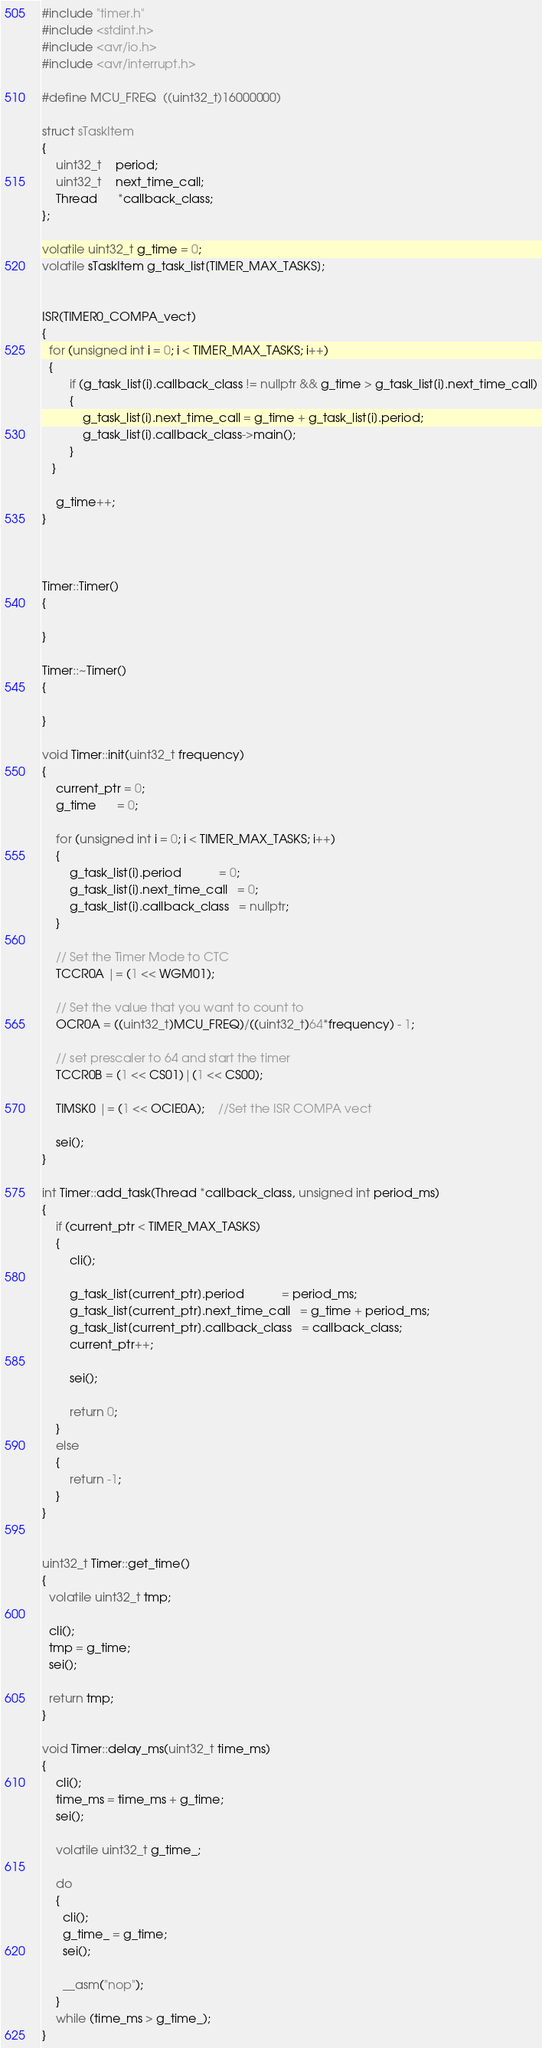Convert code to text. <code><loc_0><loc_0><loc_500><loc_500><_C++_>#include "timer.h"
#include <stdint.h>
#include <avr/io.h>
#include <avr/interrupt.h>

#define MCU_FREQ  ((uint32_t)16000000)

struct sTaskItem
{
    uint32_t    period;
    uint32_t    next_time_call;
    Thread      *callback_class;
};

volatile uint32_t g_time = 0;
volatile sTaskItem g_task_list[TIMER_MAX_TASKS];

 
ISR(TIMER0_COMPA_vect)
{
  for (unsigned int i = 0; i < TIMER_MAX_TASKS; i++)
  {
        if (g_task_list[i].callback_class != nullptr && g_time > g_task_list[i].next_time_call)
        {
            g_task_list[i].next_time_call = g_time + g_task_list[i].period;
            g_task_list[i].callback_class->main();
        }
   }

    g_time++;
}



Timer::Timer()
{
    
} 

Timer::~Timer()
{

}

void Timer::init(uint32_t frequency)
{
    current_ptr = 0;
    g_time      = 0;

    for (unsigned int i = 0; i < TIMER_MAX_TASKS; i++)
    {
        g_task_list[i].period           = 0;
        g_task_list[i].next_time_call   = 0;
        g_task_list[i].callback_class   = nullptr;
    }

    // Set the Timer Mode to CTC
    TCCR0A |= (1 << WGM01);

    // Set the value that you want to count to
    OCR0A = ((uint32_t)MCU_FREQ)/((uint32_t)64*frequency) - 1;
  
    // set prescaler to 64 and start the timer
    TCCR0B = (1 << CS01)|(1 << CS00);

    TIMSK0 |= (1 << OCIE0A);    //Set the ISR COMPA vect

    sei();
}

int Timer::add_task(Thread *callback_class, unsigned int period_ms)
{
    if (current_ptr < TIMER_MAX_TASKS)
    {
        cli();

        g_task_list[current_ptr].period           = period_ms;
        g_task_list[current_ptr].next_time_call   = g_time + period_ms;
        g_task_list[current_ptr].callback_class   = callback_class;
        current_ptr++;

        sei();

        return 0;
    }
    else
    {
        return -1;
    }
}


uint32_t Timer::get_time()
{
  volatile uint32_t tmp;

  cli();
  tmp = g_time;
  sei();

  return tmp;
}

void Timer::delay_ms(uint32_t time_ms)
{
    cli();
    time_ms = time_ms + g_time;
    sei();

    volatile uint32_t g_time_;

    do
    {
      cli();
      g_time_ = g_time;
      sei();

      __asm("nop");
    }
    while (time_ms > g_time_);
}</code> 